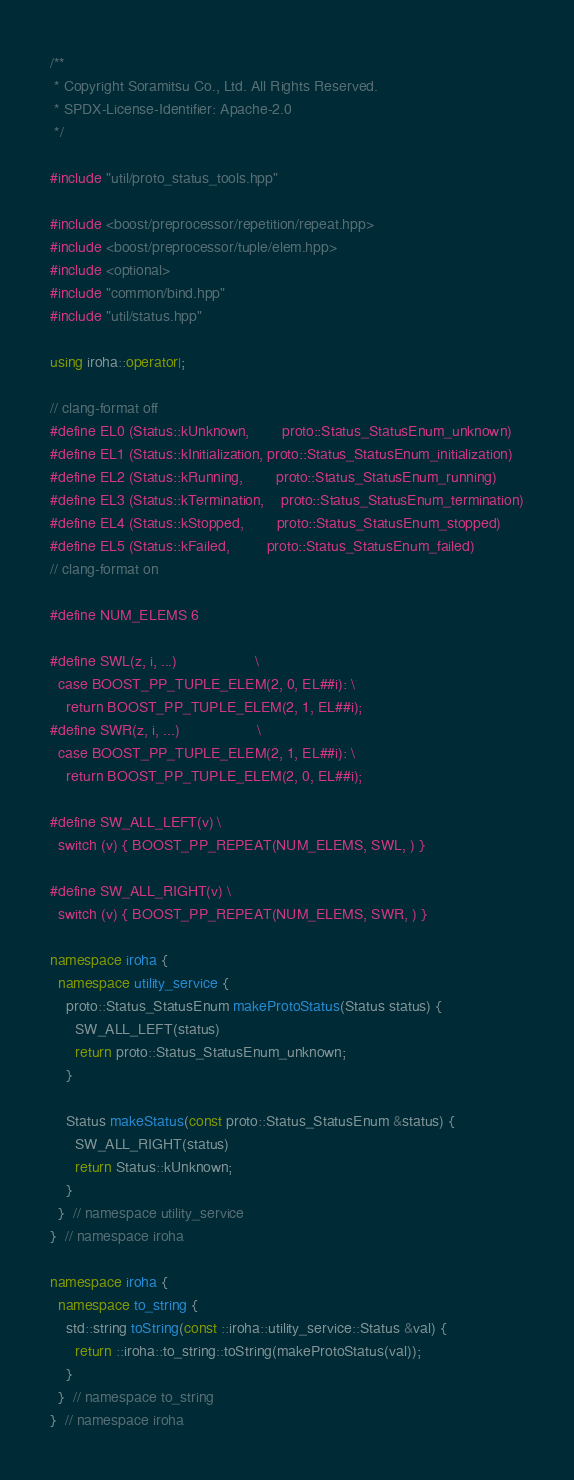<code> <loc_0><loc_0><loc_500><loc_500><_C++_>/**
 * Copyright Soramitsu Co., Ltd. All Rights Reserved.
 * SPDX-License-Identifier: Apache-2.0
 */

#include "util/proto_status_tools.hpp"

#include <boost/preprocessor/repetition/repeat.hpp>
#include <boost/preprocessor/tuple/elem.hpp>
#include <optional>
#include "common/bind.hpp"
#include "util/status.hpp"

using iroha::operator|;

// clang-format off
#define EL0 (Status::kUnknown,        proto::Status_StatusEnum_unknown)
#define EL1 (Status::kInitialization, proto::Status_StatusEnum_initialization)
#define EL2 (Status::kRunning,        proto::Status_StatusEnum_running)
#define EL3 (Status::kTermination,    proto::Status_StatusEnum_termination)
#define EL4 (Status::kStopped,        proto::Status_StatusEnum_stopped)
#define EL5 (Status::kFailed,         proto::Status_StatusEnum_failed)
// clang-format on

#define NUM_ELEMS 6

#define SWL(z, i, ...)                   \
  case BOOST_PP_TUPLE_ELEM(2, 0, EL##i): \
    return BOOST_PP_TUPLE_ELEM(2, 1, EL##i);
#define SWR(z, i, ...)                   \
  case BOOST_PP_TUPLE_ELEM(2, 1, EL##i): \
    return BOOST_PP_TUPLE_ELEM(2, 0, EL##i);

#define SW_ALL_LEFT(v) \
  switch (v) { BOOST_PP_REPEAT(NUM_ELEMS, SWL, ) }

#define SW_ALL_RIGHT(v) \
  switch (v) { BOOST_PP_REPEAT(NUM_ELEMS, SWR, ) }

namespace iroha {
  namespace utility_service {
    proto::Status_StatusEnum makeProtoStatus(Status status) {
      SW_ALL_LEFT(status)
      return proto::Status_StatusEnum_unknown;
    }

    Status makeStatus(const proto::Status_StatusEnum &status) {
      SW_ALL_RIGHT(status)
      return Status::kUnknown;
    }
  }  // namespace utility_service
}  // namespace iroha

namespace iroha {
  namespace to_string {
    std::string toString(const ::iroha::utility_service::Status &val) {
      return ::iroha::to_string::toString(makeProtoStatus(val));
    }
  }  // namespace to_string
}  // namespace iroha
</code> 